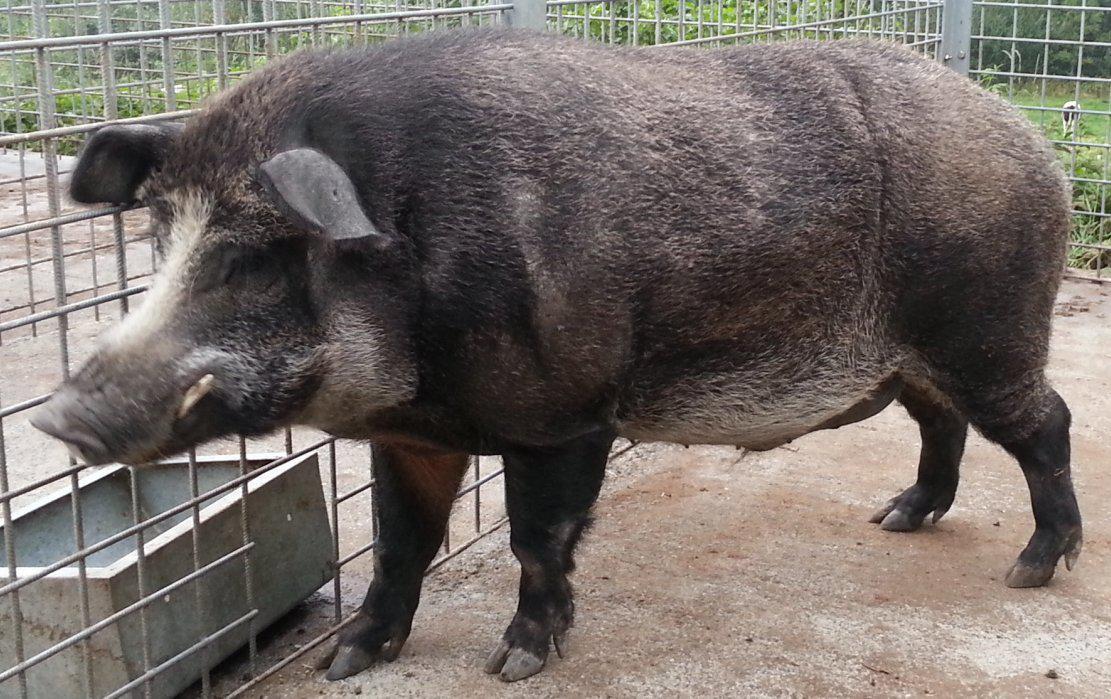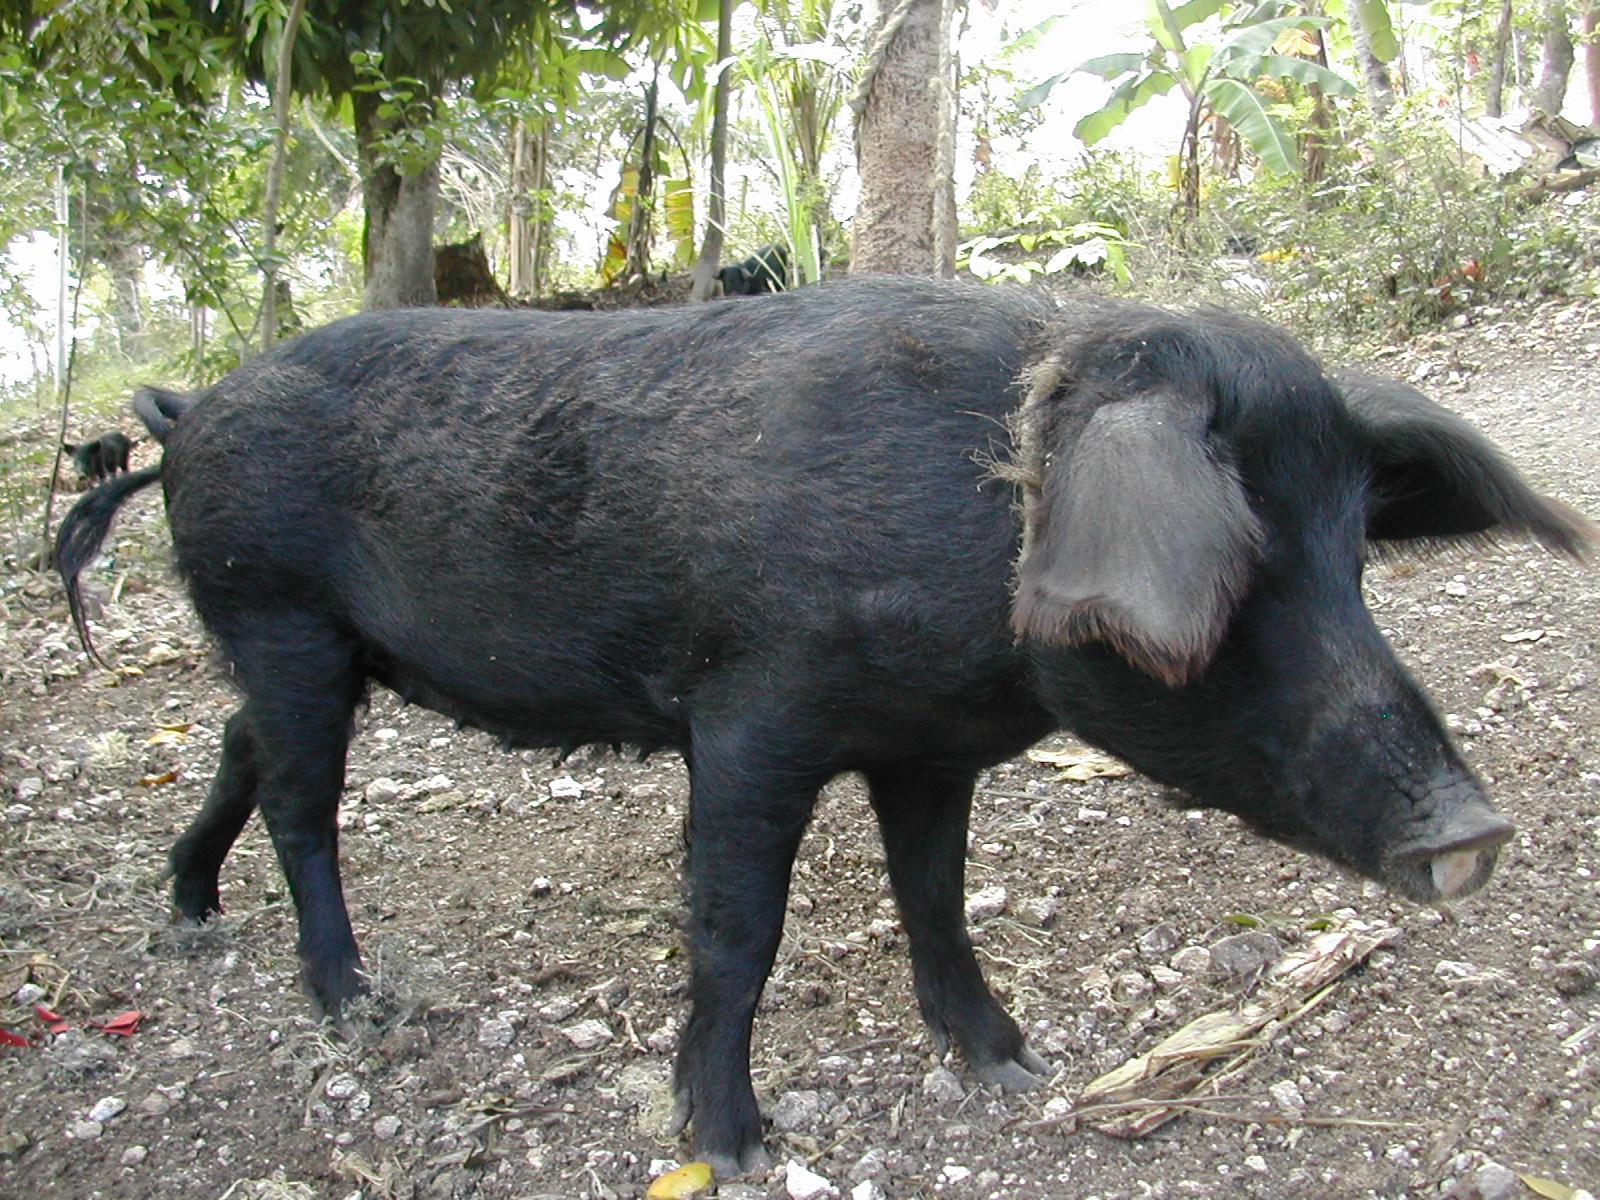The first image is the image on the left, the second image is the image on the right. For the images shown, is this caption "The left image shows only an adult boar, which is facing leftward." true? Answer yes or no. Yes. 